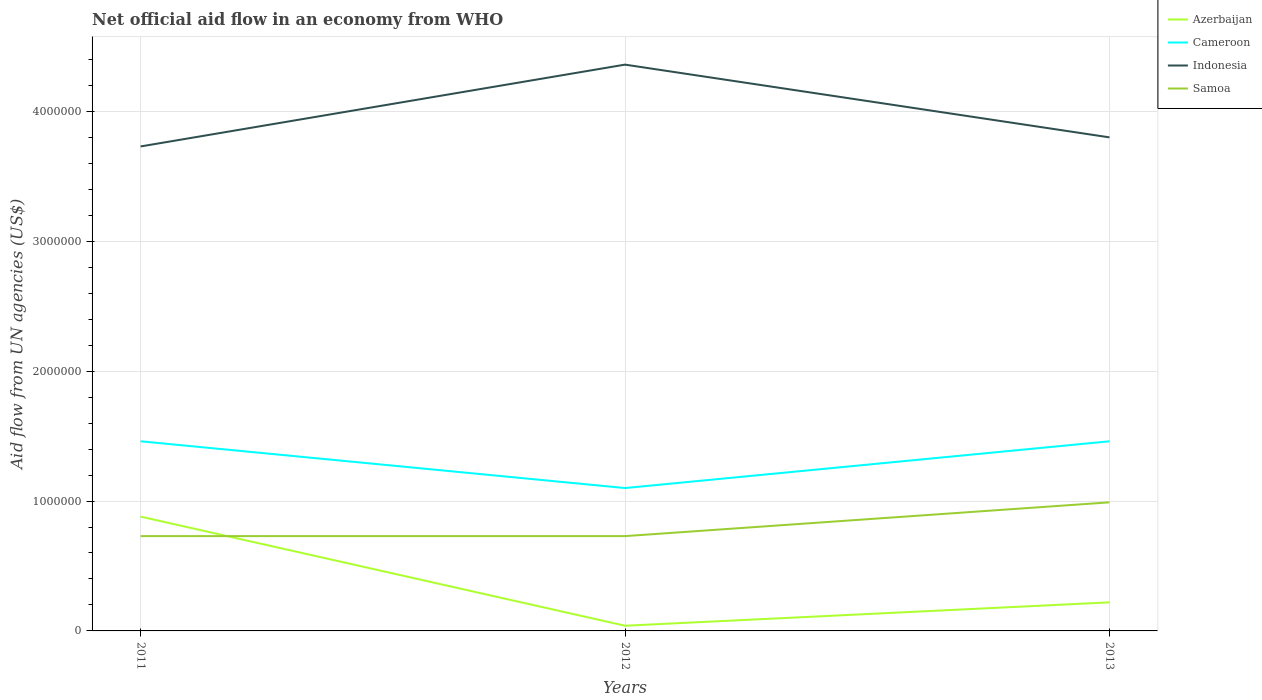Across all years, what is the maximum net official aid flow in Azerbaijan?
Keep it short and to the point. 4.00e+04. What is the total net official aid flow in Samoa in the graph?
Give a very brief answer. -2.60e+05. What is the difference between the highest and the second highest net official aid flow in Indonesia?
Provide a short and direct response. 6.30e+05. What is the difference between the highest and the lowest net official aid flow in Cameroon?
Keep it short and to the point. 2. How many years are there in the graph?
Your answer should be very brief. 3. Are the values on the major ticks of Y-axis written in scientific E-notation?
Provide a succinct answer. No. How many legend labels are there?
Your response must be concise. 4. How are the legend labels stacked?
Provide a short and direct response. Vertical. What is the title of the graph?
Offer a very short reply. Net official aid flow in an economy from WHO. What is the label or title of the Y-axis?
Make the answer very short. Aid flow from UN agencies (US$). What is the Aid flow from UN agencies (US$) in Azerbaijan in 2011?
Make the answer very short. 8.80e+05. What is the Aid flow from UN agencies (US$) in Cameroon in 2011?
Your response must be concise. 1.46e+06. What is the Aid flow from UN agencies (US$) in Indonesia in 2011?
Your response must be concise. 3.73e+06. What is the Aid flow from UN agencies (US$) in Samoa in 2011?
Give a very brief answer. 7.30e+05. What is the Aid flow from UN agencies (US$) in Cameroon in 2012?
Offer a very short reply. 1.10e+06. What is the Aid flow from UN agencies (US$) of Indonesia in 2012?
Provide a succinct answer. 4.36e+06. What is the Aid flow from UN agencies (US$) of Samoa in 2012?
Provide a succinct answer. 7.30e+05. What is the Aid flow from UN agencies (US$) of Azerbaijan in 2013?
Your answer should be very brief. 2.20e+05. What is the Aid flow from UN agencies (US$) in Cameroon in 2013?
Give a very brief answer. 1.46e+06. What is the Aid flow from UN agencies (US$) in Indonesia in 2013?
Ensure brevity in your answer.  3.80e+06. What is the Aid flow from UN agencies (US$) in Samoa in 2013?
Make the answer very short. 9.90e+05. Across all years, what is the maximum Aid flow from UN agencies (US$) of Azerbaijan?
Offer a terse response. 8.80e+05. Across all years, what is the maximum Aid flow from UN agencies (US$) in Cameroon?
Give a very brief answer. 1.46e+06. Across all years, what is the maximum Aid flow from UN agencies (US$) of Indonesia?
Keep it short and to the point. 4.36e+06. Across all years, what is the maximum Aid flow from UN agencies (US$) in Samoa?
Keep it short and to the point. 9.90e+05. Across all years, what is the minimum Aid flow from UN agencies (US$) of Azerbaijan?
Give a very brief answer. 4.00e+04. Across all years, what is the minimum Aid flow from UN agencies (US$) in Cameroon?
Your answer should be very brief. 1.10e+06. Across all years, what is the minimum Aid flow from UN agencies (US$) in Indonesia?
Ensure brevity in your answer.  3.73e+06. Across all years, what is the minimum Aid flow from UN agencies (US$) of Samoa?
Keep it short and to the point. 7.30e+05. What is the total Aid flow from UN agencies (US$) of Azerbaijan in the graph?
Offer a very short reply. 1.14e+06. What is the total Aid flow from UN agencies (US$) of Cameroon in the graph?
Provide a short and direct response. 4.02e+06. What is the total Aid flow from UN agencies (US$) of Indonesia in the graph?
Your response must be concise. 1.19e+07. What is the total Aid flow from UN agencies (US$) of Samoa in the graph?
Ensure brevity in your answer.  2.45e+06. What is the difference between the Aid flow from UN agencies (US$) of Azerbaijan in 2011 and that in 2012?
Offer a terse response. 8.40e+05. What is the difference between the Aid flow from UN agencies (US$) in Cameroon in 2011 and that in 2012?
Offer a very short reply. 3.60e+05. What is the difference between the Aid flow from UN agencies (US$) in Indonesia in 2011 and that in 2012?
Give a very brief answer. -6.30e+05. What is the difference between the Aid flow from UN agencies (US$) of Samoa in 2011 and that in 2012?
Ensure brevity in your answer.  0. What is the difference between the Aid flow from UN agencies (US$) of Azerbaijan in 2011 and that in 2013?
Your response must be concise. 6.60e+05. What is the difference between the Aid flow from UN agencies (US$) of Indonesia in 2011 and that in 2013?
Your response must be concise. -7.00e+04. What is the difference between the Aid flow from UN agencies (US$) of Cameroon in 2012 and that in 2013?
Provide a succinct answer. -3.60e+05. What is the difference between the Aid flow from UN agencies (US$) of Indonesia in 2012 and that in 2013?
Your response must be concise. 5.60e+05. What is the difference between the Aid flow from UN agencies (US$) of Azerbaijan in 2011 and the Aid flow from UN agencies (US$) of Indonesia in 2012?
Offer a very short reply. -3.48e+06. What is the difference between the Aid flow from UN agencies (US$) of Cameroon in 2011 and the Aid flow from UN agencies (US$) of Indonesia in 2012?
Your answer should be very brief. -2.90e+06. What is the difference between the Aid flow from UN agencies (US$) in Cameroon in 2011 and the Aid flow from UN agencies (US$) in Samoa in 2012?
Provide a succinct answer. 7.30e+05. What is the difference between the Aid flow from UN agencies (US$) of Azerbaijan in 2011 and the Aid flow from UN agencies (US$) of Cameroon in 2013?
Provide a short and direct response. -5.80e+05. What is the difference between the Aid flow from UN agencies (US$) in Azerbaijan in 2011 and the Aid flow from UN agencies (US$) in Indonesia in 2013?
Your response must be concise. -2.92e+06. What is the difference between the Aid flow from UN agencies (US$) in Azerbaijan in 2011 and the Aid flow from UN agencies (US$) in Samoa in 2013?
Your answer should be very brief. -1.10e+05. What is the difference between the Aid flow from UN agencies (US$) in Cameroon in 2011 and the Aid flow from UN agencies (US$) in Indonesia in 2013?
Offer a very short reply. -2.34e+06. What is the difference between the Aid flow from UN agencies (US$) in Cameroon in 2011 and the Aid flow from UN agencies (US$) in Samoa in 2013?
Offer a terse response. 4.70e+05. What is the difference between the Aid flow from UN agencies (US$) of Indonesia in 2011 and the Aid flow from UN agencies (US$) of Samoa in 2013?
Offer a terse response. 2.74e+06. What is the difference between the Aid flow from UN agencies (US$) of Azerbaijan in 2012 and the Aid flow from UN agencies (US$) of Cameroon in 2013?
Provide a succinct answer. -1.42e+06. What is the difference between the Aid flow from UN agencies (US$) of Azerbaijan in 2012 and the Aid flow from UN agencies (US$) of Indonesia in 2013?
Offer a terse response. -3.76e+06. What is the difference between the Aid flow from UN agencies (US$) of Azerbaijan in 2012 and the Aid flow from UN agencies (US$) of Samoa in 2013?
Provide a succinct answer. -9.50e+05. What is the difference between the Aid flow from UN agencies (US$) of Cameroon in 2012 and the Aid flow from UN agencies (US$) of Indonesia in 2013?
Ensure brevity in your answer.  -2.70e+06. What is the difference between the Aid flow from UN agencies (US$) of Cameroon in 2012 and the Aid flow from UN agencies (US$) of Samoa in 2013?
Keep it short and to the point. 1.10e+05. What is the difference between the Aid flow from UN agencies (US$) of Indonesia in 2012 and the Aid flow from UN agencies (US$) of Samoa in 2013?
Provide a succinct answer. 3.37e+06. What is the average Aid flow from UN agencies (US$) in Azerbaijan per year?
Your answer should be very brief. 3.80e+05. What is the average Aid flow from UN agencies (US$) in Cameroon per year?
Ensure brevity in your answer.  1.34e+06. What is the average Aid flow from UN agencies (US$) of Indonesia per year?
Offer a terse response. 3.96e+06. What is the average Aid flow from UN agencies (US$) in Samoa per year?
Provide a short and direct response. 8.17e+05. In the year 2011, what is the difference between the Aid flow from UN agencies (US$) of Azerbaijan and Aid flow from UN agencies (US$) of Cameroon?
Your answer should be very brief. -5.80e+05. In the year 2011, what is the difference between the Aid flow from UN agencies (US$) in Azerbaijan and Aid flow from UN agencies (US$) in Indonesia?
Your response must be concise. -2.85e+06. In the year 2011, what is the difference between the Aid flow from UN agencies (US$) in Azerbaijan and Aid flow from UN agencies (US$) in Samoa?
Ensure brevity in your answer.  1.50e+05. In the year 2011, what is the difference between the Aid flow from UN agencies (US$) in Cameroon and Aid flow from UN agencies (US$) in Indonesia?
Your answer should be very brief. -2.27e+06. In the year 2011, what is the difference between the Aid flow from UN agencies (US$) of Cameroon and Aid flow from UN agencies (US$) of Samoa?
Make the answer very short. 7.30e+05. In the year 2011, what is the difference between the Aid flow from UN agencies (US$) of Indonesia and Aid flow from UN agencies (US$) of Samoa?
Ensure brevity in your answer.  3.00e+06. In the year 2012, what is the difference between the Aid flow from UN agencies (US$) of Azerbaijan and Aid flow from UN agencies (US$) of Cameroon?
Offer a very short reply. -1.06e+06. In the year 2012, what is the difference between the Aid flow from UN agencies (US$) in Azerbaijan and Aid flow from UN agencies (US$) in Indonesia?
Keep it short and to the point. -4.32e+06. In the year 2012, what is the difference between the Aid flow from UN agencies (US$) of Azerbaijan and Aid flow from UN agencies (US$) of Samoa?
Give a very brief answer. -6.90e+05. In the year 2012, what is the difference between the Aid flow from UN agencies (US$) of Cameroon and Aid flow from UN agencies (US$) of Indonesia?
Keep it short and to the point. -3.26e+06. In the year 2012, what is the difference between the Aid flow from UN agencies (US$) of Indonesia and Aid flow from UN agencies (US$) of Samoa?
Keep it short and to the point. 3.63e+06. In the year 2013, what is the difference between the Aid flow from UN agencies (US$) of Azerbaijan and Aid flow from UN agencies (US$) of Cameroon?
Offer a terse response. -1.24e+06. In the year 2013, what is the difference between the Aid flow from UN agencies (US$) in Azerbaijan and Aid flow from UN agencies (US$) in Indonesia?
Ensure brevity in your answer.  -3.58e+06. In the year 2013, what is the difference between the Aid flow from UN agencies (US$) in Azerbaijan and Aid flow from UN agencies (US$) in Samoa?
Your answer should be compact. -7.70e+05. In the year 2013, what is the difference between the Aid flow from UN agencies (US$) of Cameroon and Aid flow from UN agencies (US$) of Indonesia?
Provide a short and direct response. -2.34e+06. In the year 2013, what is the difference between the Aid flow from UN agencies (US$) in Cameroon and Aid flow from UN agencies (US$) in Samoa?
Make the answer very short. 4.70e+05. In the year 2013, what is the difference between the Aid flow from UN agencies (US$) in Indonesia and Aid flow from UN agencies (US$) in Samoa?
Offer a terse response. 2.81e+06. What is the ratio of the Aid flow from UN agencies (US$) in Azerbaijan in 2011 to that in 2012?
Offer a terse response. 22. What is the ratio of the Aid flow from UN agencies (US$) in Cameroon in 2011 to that in 2012?
Offer a terse response. 1.33. What is the ratio of the Aid flow from UN agencies (US$) of Indonesia in 2011 to that in 2012?
Your answer should be compact. 0.86. What is the ratio of the Aid flow from UN agencies (US$) of Azerbaijan in 2011 to that in 2013?
Ensure brevity in your answer.  4. What is the ratio of the Aid flow from UN agencies (US$) in Indonesia in 2011 to that in 2013?
Your answer should be compact. 0.98. What is the ratio of the Aid flow from UN agencies (US$) of Samoa in 2011 to that in 2013?
Your answer should be very brief. 0.74. What is the ratio of the Aid flow from UN agencies (US$) in Azerbaijan in 2012 to that in 2013?
Give a very brief answer. 0.18. What is the ratio of the Aid flow from UN agencies (US$) of Cameroon in 2012 to that in 2013?
Your answer should be very brief. 0.75. What is the ratio of the Aid flow from UN agencies (US$) in Indonesia in 2012 to that in 2013?
Make the answer very short. 1.15. What is the ratio of the Aid flow from UN agencies (US$) of Samoa in 2012 to that in 2013?
Offer a terse response. 0.74. What is the difference between the highest and the second highest Aid flow from UN agencies (US$) of Cameroon?
Your answer should be compact. 0. What is the difference between the highest and the second highest Aid flow from UN agencies (US$) of Indonesia?
Keep it short and to the point. 5.60e+05. What is the difference between the highest and the second highest Aid flow from UN agencies (US$) of Samoa?
Keep it short and to the point. 2.60e+05. What is the difference between the highest and the lowest Aid flow from UN agencies (US$) of Azerbaijan?
Ensure brevity in your answer.  8.40e+05. What is the difference between the highest and the lowest Aid flow from UN agencies (US$) of Cameroon?
Ensure brevity in your answer.  3.60e+05. What is the difference between the highest and the lowest Aid flow from UN agencies (US$) in Indonesia?
Offer a terse response. 6.30e+05. 